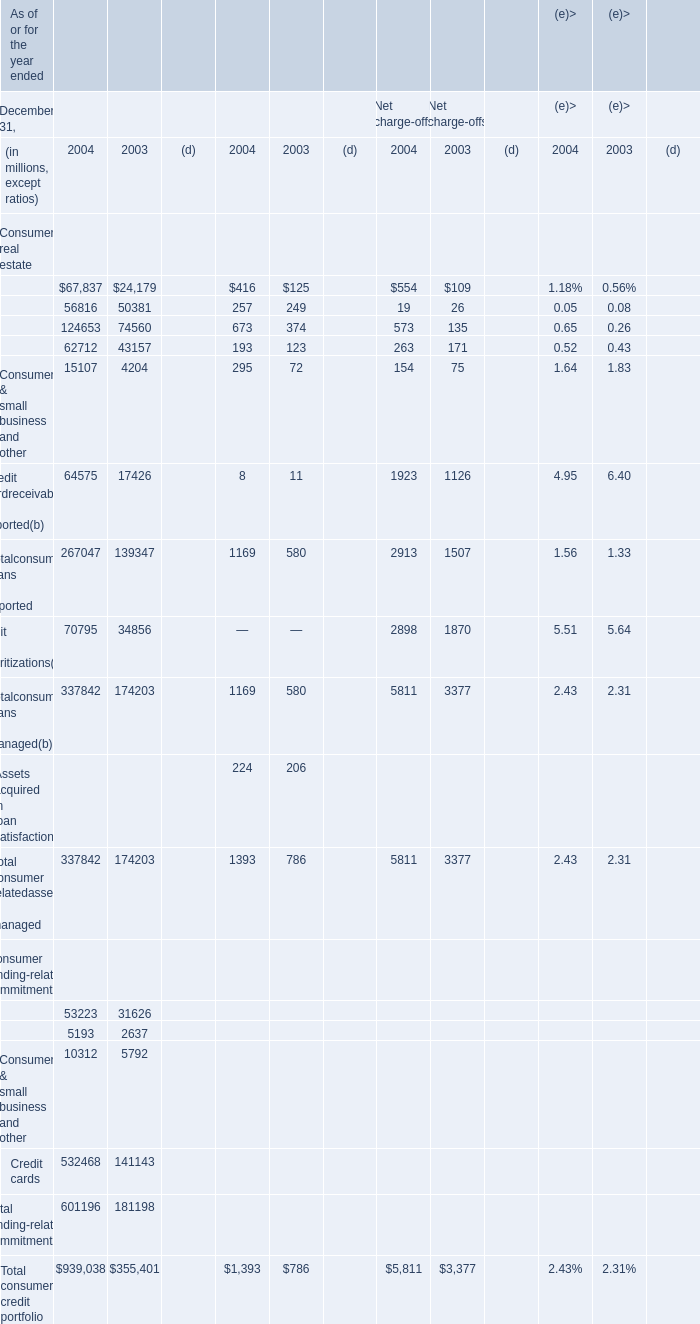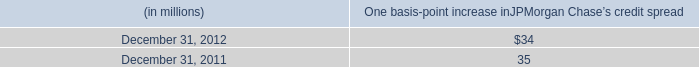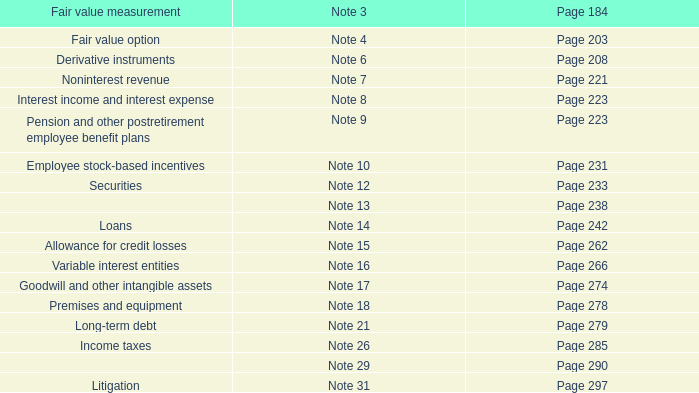What's the sum of all Home finance– home equity and other(a that are greater than 100 in 2004? (in million) 
Computations: (67837 + 416)
Answer: 68253.0. 